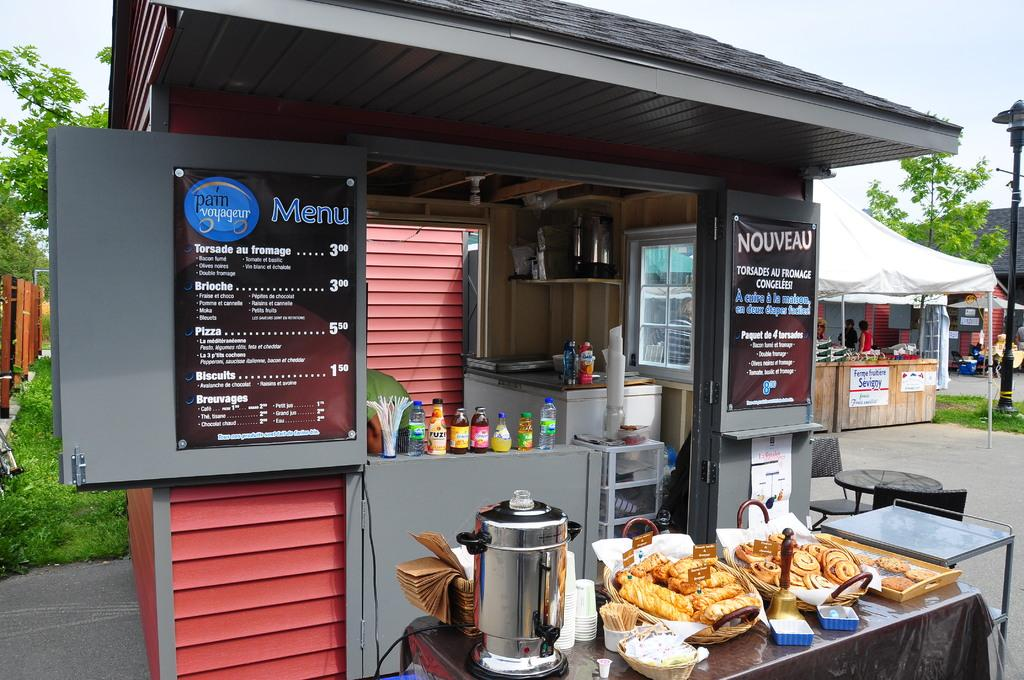<image>
Give a short and clear explanation of the subsequent image. a little food area with a Menu on the house 